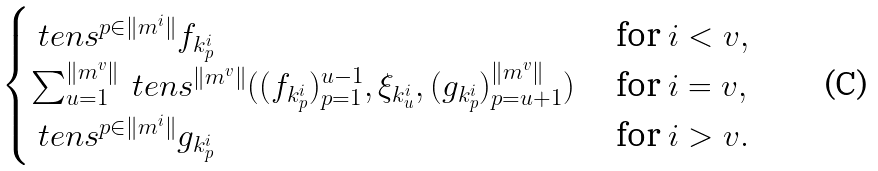Convert formula to latex. <formula><loc_0><loc_0><loc_500><loc_500>\begin{cases} \ t e n s ^ { p \in \| m ^ { i } \| } f _ { k ^ { i } _ { p } } & \text { for } i < v , \\ \sum _ { u = 1 } ^ { \| m ^ { v } \| } \ t e n s ^ { \| m ^ { v } \| } ( ( f _ { k _ { p } ^ { i } } ) _ { p = 1 } ^ { u - 1 } , \xi _ { k _ { u } ^ { i } } , ( g _ { k _ { p } ^ { i } } ) _ { p = u + 1 } ^ { \| m ^ { v } \| } ) & \text { for } i = v , \\ \ t e n s ^ { p \in \| m ^ { i } \| } g _ { k ^ { i } _ { p } } & \text { for } i > v . \end{cases}</formula> 